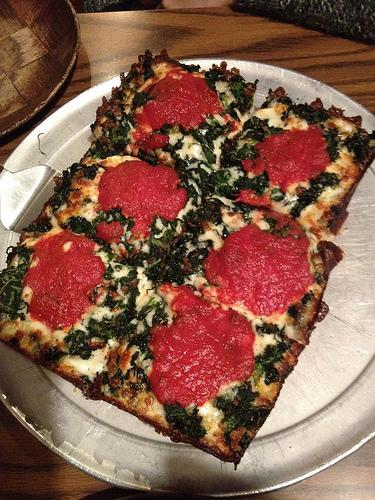Question: what is the color of the tray?
Choices:
A. Black.
B. Green.
C. Red.
D. Silver.
Answer with the letter. Answer: D Question: what is the make of the table?
Choices:
A. Plastic.
B. Wood.
C. Stainless Steel.
D. Cherrywood.
Answer with the letter. Answer: B Question: when was the pic taken?
Choices:
A. At dawn.
B. At dusk.
C. At sunset.
D. During the day.
Answer with the letter. Answer: D Question: how many pizzas are there?
Choices:
A. 2.
B. 3.
C. 4.
D. 1.
Answer with the letter. Answer: D 